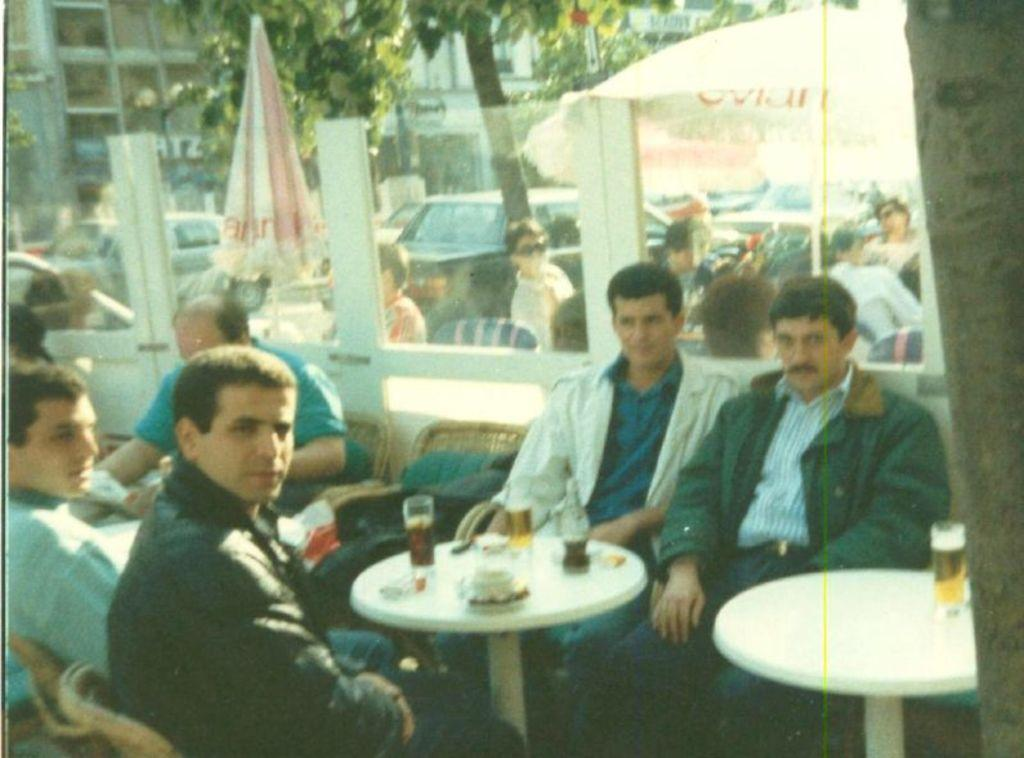What are the people in the image doing? The people in the image are sitting on chairs near a table. What can be seen in the background of the image? In the background, there are umbrellas, cars, buildings, and trees. Can you describe the setting of the image? The image appears to be set outdoors, with people sitting near a table and various background elements visible. What religious ceremony is taking place in the image? There is no indication of a religious ceremony in the image; it simply shows people sitting near a table with various background elements. 